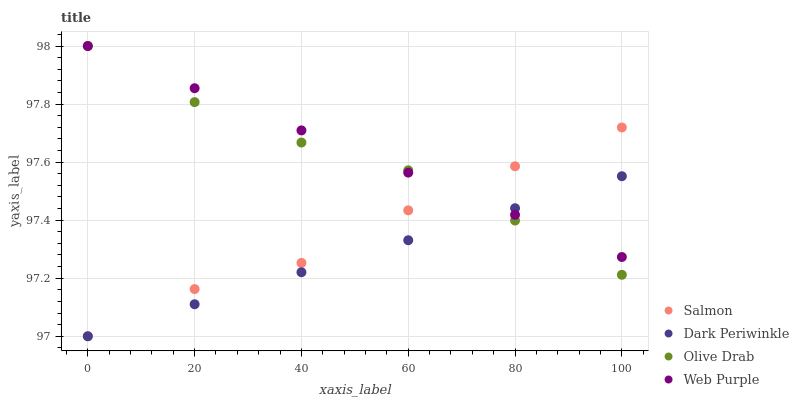Does Dark Periwinkle have the minimum area under the curve?
Answer yes or no. Yes. Does Web Purple have the maximum area under the curve?
Answer yes or no. Yes. Does Salmon have the minimum area under the curve?
Answer yes or no. No. Does Salmon have the maximum area under the curve?
Answer yes or no. No. Is Web Purple the smoothest?
Answer yes or no. Yes. Is Salmon the roughest?
Answer yes or no. Yes. Is Dark Periwinkle the smoothest?
Answer yes or no. No. Is Dark Periwinkle the roughest?
Answer yes or no. No. Does Salmon have the lowest value?
Answer yes or no. Yes. Does Olive Drab have the lowest value?
Answer yes or no. No. Does Olive Drab have the highest value?
Answer yes or no. Yes. Does Salmon have the highest value?
Answer yes or no. No. Does Dark Periwinkle intersect Web Purple?
Answer yes or no. Yes. Is Dark Periwinkle less than Web Purple?
Answer yes or no. No. Is Dark Periwinkle greater than Web Purple?
Answer yes or no. No. 